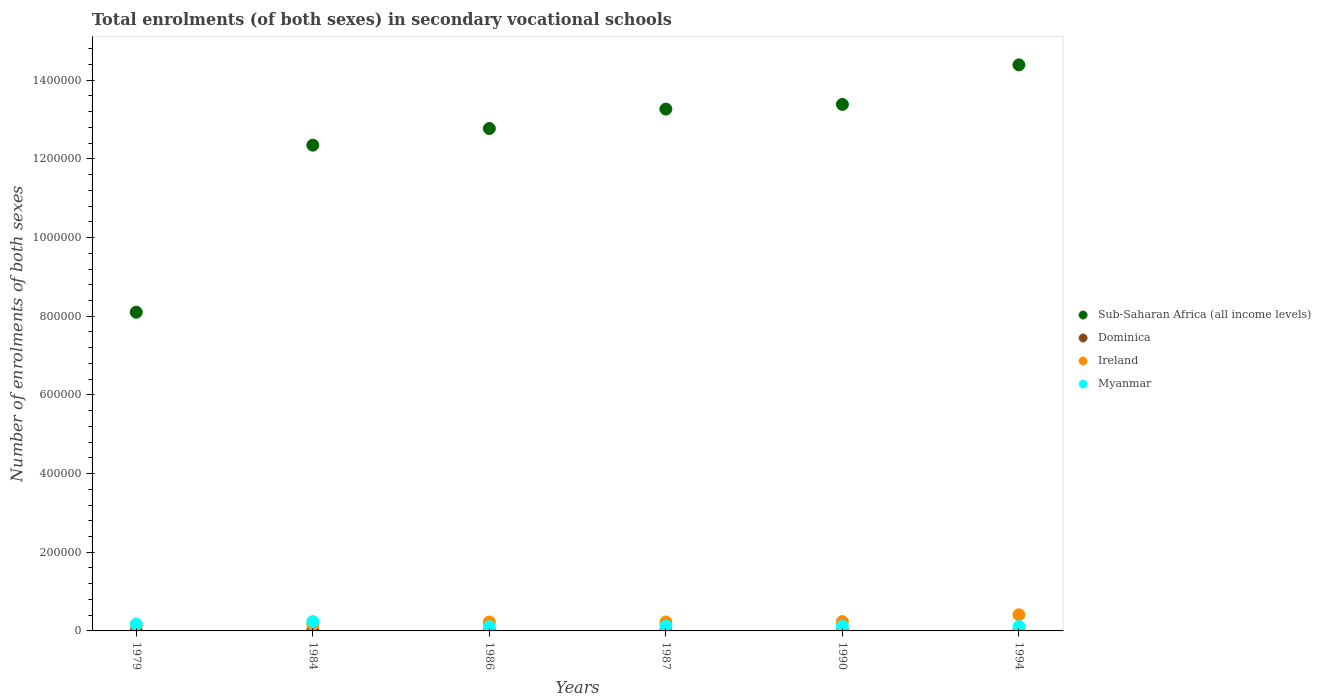Is the number of dotlines equal to the number of legend labels?
Your answer should be very brief. Yes. What is the number of enrolments in secondary schools in Sub-Saharan Africa (all income levels) in 1987?
Provide a succinct answer. 1.33e+06. Across all years, what is the maximum number of enrolments in secondary schools in Ireland?
Make the answer very short. 4.11e+04. Across all years, what is the minimum number of enrolments in secondary schools in Ireland?
Offer a very short reply. 1.47e+04. In which year was the number of enrolments in secondary schools in Dominica maximum?
Your answer should be very brief. 1994. In which year was the number of enrolments in secondary schools in Sub-Saharan Africa (all income levels) minimum?
Your answer should be compact. 1979. What is the total number of enrolments in secondary schools in Sub-Saharan Africa (all income levels) in the graph?
Your response must be concise. 7.43e+06. What is the difference between the number of enrolments in secondary schools in Ireland in 1984 and that in 1987?
Your answer should be compact. -6729. What is the difference between the number of enrolments in secondary schools in Myanmar in 1990 and the number of enrolments in secondary schools in Sub-Saharan Africa (all income levels) in 1987?
Give a very brief answer. -1.32e+06. What is the average number of enrolments in secondary schools in Myanmar per year?
Offer a very short reply. 1.45e+04. In the year 1990, what is the difference between the number of enrolments in secondary schools in Sub-Saharan Africa (all income levels) and number of enrolments in secondary schools in Dominica?
Ensure brevity in your answer.  1.34e+06. What is the ratio of the number of enrolments in secondary schools in Myanmar in 1986 to that in 1987?
Keep it short and to the point. 0.89. What is the difference between the highest and the second highest number of enrolments in secondary schools in Sub-Saharan Africa (all income levels)?
Offer a very short reply. 1.00e+05. What is the difference between the highest and the lowest number of enrolments in secondary schools in Myanmar?
Your response must be concise. 1.28e+04. Is the sum of the number of enrolments in secondary schools in Sub-Saharan Africa (all income levels) in 1984 and 1986 greater than the maximum number of enrolments in secondary schools in Dominica across all years?
Your answer should be very brief. Yes. Are the values on the major ticks of Y-axis written in scientific E-notation?
Provide a succinct answer. No. Does the graph contain any zero values?
Offer a very short reply. No. What is the title of the graph?
Make the answer very short. Total enrolments (of both sexes) in secondary vocational schools. What is the label or title of the X-axis?
Ensure brevity in your answer.  Years. What is the label or title of the Y-axis?
Keep it short and to the point. Number of enrolments of both sexes. What is the Number of enrolments of both sexes of Sub-Saharan Africa (all income levels) in 1979?
Make the answer very short. 8.10e+05. What is the Number of enrolments of both sexes in Dominica in 1979?
Make the answer very short. 436. What is the Number of enrolments of both sexes of Ireland in 1979?
Make the answer very short. 1.47e+04. What is the Number of enrolments of both sexes in Myanmar in 1979?
Make the answer very short. 1.75e+04. What is the Number of enrolments of both sexes of Sub-Saharan Africa (all income levels) in 1984?
Give a very brief answer. 1.23e+06. What is the Number of enrolments of both sexes in Dominica in 1984?
Your response must be concise. 376. What is the Number of enrolments of both sexes of Ireland in 1984?
Give a very brief answer. 1.60e+04. What is the Number of enrolments of both sexes of Myanmar in 1984?
Offer a very short reply. 2.37e+04. What is the Number of enrolments of both sexes of Sub-Saharan Africa (all income levels) in 1986?
Your answer should be compact. 1.28e+06. What is the Number of enrolments of both sexes of Dominica in 1986?
Provide a succinct answer. 259. What is the Number of enrolments of both sexes in Ireland in 1986?
Keep it short and to the point. 2.27e+04. What is the Number of enrolments of both sexes in Myanmar in 1986?
Make the answer very short. 1.09e+04. What is the Number of enrolments of both sexes in Sub-Saharan Africa (all income levels) in 1987?
Give a very brief answer. 1.33e+06. What is the Number of enrolments of both sexes of Ireland in 1987?
Your answer should be compact. 2.27e+04. What is the Number of enrolments of both sexes in Myanmar in 1987?
Give a very brief answer. 1.22e+04. What is the Number of enrolments of both sexes of Sub-Saharan Africa (all income levels) in 1990?
Make the answer very short. 1.34e+06. What is the Number of enrolments of both sexes in Dominica in 1990?
Offer a very short reply. 604. What is the Number of enrolments of both sexes in Ireland in 1990?
Make the answer very short. 2.38e+04. What is the Number of enrolments of both sexes in Myanmar in 1990?
Ensure brevity in your answer.  1.16e+04. What is the Number of enrolments of both sexes of Sub-Saharan Africa (all income levels) in 1994?
Your response must be concise. 1.44e+06. What is the Number of enrolments of both sexes of Dominica in 1994?
Offer a terse response. 800. What is the Number of enrolments of both sexes of Ireland in 1994?
Your answer should be compact. 4.11e+04. What is the Number of enrolments of both sexes of Myanmar in 1994?
Keep it short and to the point. 1.12e+04. Across all years, what is the maximum Number of enrolments of both sexes in Sub-Saharan Africa (all income levels)?
Offer a very short reply. 1.44e+06. Across all years, what is the maximum Number of enrolments of both sexes in Dominica?
Offer a terse response. 800. Across all years, what is the maximum Number of enrolments of both sexes of Ireland?
Ensure brevity in your answer.  4.11e+04. Across all years, what is the maximum Number of enrolments of both sexes in Myanmar?
Keep it short and to the point. 2.37e+04. Across all years, what is the minimum Number of enrolments of both sexes in Sub-Saharan Africa (all income levels)?
Offer a very short reply. 8.10e+05. Across all years, what is the minimum Number of enrolments of both sexes in Dominica?
Your response must be concise. 70. Across all years, what is the minimum Number of enrolments of both sexes of Ireland?
Offer a terse response. 1.47e+04. Across all years, what is the minimum Number of enrolments of both sexes in Myanmar?
Provide a succinct answer. 1.09e+04. What is the total Number of enrolments of both sexes in Sub-Saharan Africa (all income levels) in the graph?
Offer a very short reply. 7.43e+06. What is the total Number of enrolments of both sexes of Dominica in the graph?
Your answer should be compact. 2545. What is the total Number of enrolments of both sexes in Ireland in the graph?
Your response must be concise. 1.41e+05. What is the total Number of enrolments of both sexes in Myanmar in the graph?
Offer a very short reply. 8.70e+04. What is the difference between the Number of enrolments of both sexes of Sub-Saharan Africa (all income levels) in 1979 and that in 1984?
Make the answer very short. -4.25e+05. What is the difference between the Number of enrolments of both sexes in Dominica in 1979 and that in 1984?
Your answer should be very brief. 60. What is the difference between the Number of enrolments of both sexes of Ireland in 1979 and that in 1984?
Ensure brevity in your answer.  -1269. What is the difference between the Number of enrolments of both sexes in Myanmar in 1979 and that in 1984?
Your answer should be compact. -6200. What is the difference between the Number of enrolments of both sexes of Sub-Saharan Africa (all income levels) in 1979 and that in 1986?
Give a very brief answer. -4.67e+05. What is the difference between the Number of enrolments of both sexes of Dominica in 1979 and that in 1986?
Make the answer very short. 177. What is the difference between the Number of enrolments of both sexes in Ireland in 1979 and that in 1986?
Offer a very short reply. -7943. What is the difference between the Number of enrolments of both sexes of Myanmar in 1979 and that in 1986?
Offer a very short reply. 6613. What is the difference between the Number of enrolments of both sexes in Sub-Saharan Africa (all income levels) in 1979 and that in 1987?
Your answer should be compact. -5.16e+05. What is the difference between the Number of enrolments of both sexes of Dominica in 1979 and that in 1987?
Keep it short and to the point. 366. What is the difference between the Number of enrolments of both sexes in Ireland in 1979 and that in 1987?
Ensure brevity in your answer.  -7998. What is the difference between the Number of enrolments of both sexes in Myanmar in 1979 and that in 1987?
Ensure brevity in your answer.  5295. What is the difference between the Number of enrolments of both sexes in Sub-Saharan Africa (all income levels) in 1979 and that in 1990?
Give a very brief answer. -5.28e+05. What is the difference between the Number of enrolments of both sexes in Dominica in 1979 and that in 1990?
Your answer should be compact. -168. What is the difference between the Number of enrolments of both sexes of Ireland in 1979 and that in 1990?
Offer a terse response. -9034. What is the difference between the Number of enrolments of both sexes in Myanmar in 1979 and that in 1990?
Provide a short and direct response. 5939. What is the difference between the Number of enrolments of both sexes in Sub-Saharan Africa (all income levels) in 1979 and that in 1994?
Ensure brevity in your answer.  -6.29e+05. What is the difference between the Number of enrolments of both sexes of Dominica in 1979 and that in 1994?
Your response must be concise. -364. What is the difference between the Number of enrolments of both sexes in Ireland in 1979 and that in 1994?
Offer a very short reply. -2.63e+04. What is the difference between the Number of enrolments of both sexes of Myanmar in 1979 and that in 1994?
Provide a short and direct response. 6337. What is the difference between the Number of enrolments of both sexes in Sub-Saharan Africa (all income levels) in 1984 and that in 1986?
Offer a very short reply. -4.24e+04. What is the difference between the Number of enrolments of both sexes of Dominica in 1984 and that in 1986?
Your answer should be compact. 117. What is the difference between the Number of enrolments of both sexes of Ireland in 1984 and that in 1986?
Give a very brief answer. -6674. What is the difference between the Number of enrolments of both sexes of Myanmar in 1984 and that in 1986?
Provide a succinct answer. 1.28e+04. What is the difference between the Number of enrolments of both sexes of Sub-Saharan Africa (all income levels) in 1984 and that in 1987?
Offer a terse response. -9.17e+04. What is the difference between the Number of enrolments of both sexes in Dominica in 1984 and that in 1987?
Ensure brevity in your answer.  306. What is the difference between the Number of enrolments of both sexes of Ireland in 1984 and that in 1987?
Give a very brief answer. -6729. What is the difference between the Number of enrolments of both sexes in Myanmar in 1984 and that in 1987?
Give a very brief answer. 1.15e+04. What is the difference between the Number of enrolments of both sexes of Sub-Saharan Africa (all income levels) in 1984 and that in 1990?
Offer a terse response. -1.04e+05. What is the difference between the Number of enrolments of both sexes in Dominica in 1984 and that in 1990?
Your answer should be compact. -228. What is the difference between the Number of enrolments of both sexes of Ireland in 1984 and that in 1990?
Your response must be concise. -7765. What is the difference between the Number of enrolments of both sexes of Myanmar in 1984 and that in 1990?
Offer a terse response. 1.21e+04. What is the difference between the Number of enrolments of both sexes in Sub-Saharan Africa (all income levels) in 1984 and that in 1994?
Keep it short and to the point. -2.04e+05. What is the difference between the Number of enrolments of both sexes in Dominica in 1984 and that in 1994?
Provide a short and direct response. -424. What is the difference between the Number of enrolments of both sexes of Ireland in 1984 and that in 1994?
Make the answer very short. -2.51e+04. What is the difference between the Number of enrolments of both sexes in Myanmar in 1984 and that in 1994?
Give a very brief answer. 1.25e+04. What is the difference between the Number of enrolments of both sexes of Sub-Saharan Africa (all income levels) in 1986 and that in 1987?
Offer a terse response. -4.94e+04. What is the difference between the Number of enrolments of both sexes in Dominica in 1986 and that in 1987?
Your answer should be very brief. 189. What is the difference between the Number of enrolments of both sexes in Ireland in 1986 and that in 1987?
Make the answer very short. -55. What is the difference between the Number of enrolments of both sexes in Myanmar in 1986 and that in 1987?
Provide a succinct answer. -1318. What is the difference between the Number of enrolments of both sexes in Sub-Saharan Africa (all income levels) in 1986 and that in 1990?
Offer a very short reply. -6.13e+04. What is the difference between the Number of enrolments of both sexes in Dominica in 1986 and that in 1990?
Provide a succinct answer. -345. What is the difference between the Number of enrolments of both sexes of Ireland in 1986 and that in 1990?
Provide a short and direct response. -1091. What is the difference between the Number of enrolments of both sexes in Myanmar in 1986 and that in 1990?
Make the answer very short. -674. What is the difference between the Number of enrolments of both sexes in Sub-Saharan Africa (all income levels) in 1986 and that in 1994?
Your answer should be very brief. -1.62e+05. What is the difference between the Number of enrolments of both sexes in Dominica in 1986 and that in 1994?
Offer a terse response. -541. What is the difference between the Number of enrolments of both sexes in Ireland in 1986 and that in 1994?
Your answer should be compact. -1.84e+04. What is the difference between the Number of enrolments of both sexes of Myanmar in 1986 and that in 1994?
Offer a terse response. -276. What is the difference between the Number of enrolments of both sexes in Sub-Saharan Africa (all income levels) in 1987 and that in 1990?
Ensure brevity in your answer.  -1.19e+04. What is the difference between the Number of enrolments of both sexes in Dominica in 1987 and that in 1990?
Your answer should be compact. -534. What is the difference between the Number of enrolments of both sexes of Ireland in 1987 and that in 1990?
Ensure brevity in your answer.  -1036. What is the difference between the Number of enrolments of both sexes of Myanmar in 1987 and that in 1990?
Your response must be concise. 644. What is the difference between the Number of enrolments of both sexes in Sub-Saharan Africa (all income levels) in 1987 and that in 1994?
Your answer should be compact. -1.12e+05. What is the difference between the Number of enrolments of both sexes of Dominica in 1987 and that in 1994?
Give a very brief answer. -730. What is the difference between the Number of enrolments of both sexes in Ireland in 1987 and that in 1994?
Give a very brief answer. -1.83e+04. What is the difference between the Number of enrolments of both sexes in Myanmar in 1987 and that in 1994?
Keep it short and to the point. 1042. What is the difference between the Number of enrolments of both sexes of Sub-Saharan Africa (all income levels) in 1990 and that in 1994?
Keep it short and to the point. -1.00e+05. What is the difference between the Number of enrolments of both sexes of Dominica in 1990 and that in 1994?
Your answer should be compact. -196. What is the difference between the Number of enrolments of both sexes of Ireland in 1990 and that in 1994?
Your answer should be very brief. -1.73e+04. What is the difference between the Number of enrolments of both sexes of Myanmar in 1990 and that in 1994?
Provide a short and direct response. 398. What is the difference between the Number of enrolments of both sexes of Sub-Saharan Africa (all income levels) in 1979 and the Number of enrolments of both sexes of Dominica in 1984?
Your response must be concise. 8.10e+05. What is the difference between the Number of enrolments of both sexes in Sub-Saharan Africa (all income levels) in 1979 and the Number of enrolments of both sexes in Ireland in 1984?
Offer a terse response. 7.94e+05. What is the difference between the Number of enrolments of both sexes of Sub-Saharan Africa (all income levels) in 1979 and the Number of enrolments of both sexes of Myanmar in 1984?
Provide a succinct answer. 7.87e+05. What is the difference between the Number of enrolments of both sexes in Dominica in 1979 and the Number of enrolments of both sexes in Ireland in 1984?
Your answer should be very brief. -1.56e+04. What is the difference between the Number of enrolments of both sexes of Dominica in 1979 and the Number of enrolments of both sexes of Myanmar in 1984?
Provide a succinct answer. -2.33e+04. What is the difference between the Number of enrolments of both sexes in Ireland in 1979 and the Number of enrolments of both sexes in Myanmar in 1984?
Offer a very short reply. -8971. What is the difference between the Number of enrolments of both sexes in Sub-Saharan Africa (all income levels) in 1979 and the Number of enrolments of both sexes in Dominica in 1986?
Your answer should be compact. 8.10e+05. What is the difference between the Number of enrolments of both sexes in Sub-Saharan Africa (all income levels) in 1979 and the Number of enrolments of both sexes in Ireland in 1986?
Your response must be concise. 7.88e+05. What is the difference between the Number of enrolments of both sexes of Sub-Saharan Africa (all income levels) in 1979 and the Number of enrolments of both sexes of Myanmar in 1986?
Your answer should be very brief. 7.99e+05. What is the difference between the Number of enrolments of both sexes of Dominica in 1979 and the Number of enrolments of both sexes of Ireland in 1986?
Your response must be concise. -2.22e+04. What is the difference between the Number of enrolments of both sexes in Dominica in 1979 and the Number of enrolments of both sexes in Myanmar in 1986?
Provide a succinct answer. -1.05e+04. What is the difference between the Number of enrolments of both sexes in Ireland in 1979 and the Number of enrolments of both sexes in Myanmar in 1986?
Your answer should be very brief. 3842. What is the difference between the Number of enrolments of both sexes of Sub-Saharan Africa (all income levels) in 1979 and the Number of enrolments of both sexes of Dominica in 1987?
Provide a succinct answer. 8.10e+05. What is the difference between the Number of enrolments of both sexes in Sub-Saharan Africa (all income levels) in 1979 and the Number of enrolments of both sexes in Ireland in 1987?
Your answer should be compact. 7.87e+05. What is the difference between the Number of enrolments of both sexes in Sub-Saharan Africa (all income levels) in 1979 and the Number of enrolments of both sexes in Myanmar in 1987?
Your response must be concise. 7.98e+05. What is the difference between the Number of enrolments of both sexes of Dominica in 1979 and the Number of enrolments of both sexes of Ireland in 1987?
Your answer should be compact. -2.23e+04. What is the difference between the Number of enrolments of both sexes in Dominica in 1979 and the Number of enrolments of both sexes in Myanmar in 1987?
Provide a short and direct response. -1.18e+04. What is the difference between the Number of enrolments of both sexes in Ireland in 1979 and the Number of enrolments of both sexes in Myanmar in 1987?
Your response must be concise. 2524. What is the difference between the Number of enrolments of both sexes of Sub-Saharan Africa (all income levels) in 1979 and the Number of enrolments of both sexes of Dominica in 1990?
Offer a terse response. 8.10e+05. What is the difference between the Number of enrolments of both sexes in Sub-Saharan Africa (all income levels) in 1979 and the Number of enrolments of both sexes in Ireland in 1990?
Offer a terse response. 7.86e+05. What is the difference between the Number of enrolments of both sexes of Sub-Saharan Africa (all income levels) in 1979 and the Number of enrolments of both sexes of Myanmar in 1990?
Your response must be concise. 7.99e+05. What is the difference between the Number of enrolments of both sexes of Dominica in 1979 and the Number of enrolments of both sexes of Ireland in 1990?
Your answer should be very brief. -2.33e+04. What is the difference between the Number of enrolments of both sexes of Dominica in 1979 and the Number of enrolments of both sexes of Myanmar in 1990?
Give a very brief answer. -1.11e+04. What is the difference between the Number of enrolments of both sexes in Ireland in 1979 and the Number of enrolments of both sexes in Myanmar in 1990?
Keep it short and to the point. 3168. What is the difference between the Number of enrolments of both sexes of Sub-Saharan Africa (all income levels) in 1979 and the Number of enrolments of both sexes of Dominica in 1994?
Your answer should be compact. 8.09e+05. What is the difference between the Number of enrolments of both sexes in Sub-Saharan Africa (all income levels) in 1979 and the Number of enrolments of both sexes in Ireland in 1994?
Your answer should be compact. 7.69e+05. What is the difference between the Number of enrolments of both sexes in Sub-Saharan Africa (all income levels) in 1979 and the Number of enrolments of both sexes in Myanmar in 1994?
Give a very brief answer. 7.99e+05. What is the difference between the Number of enrolments of both sexes of Dominica in 1979 and the Number of enrolments of both sexes of Ireland in 1994?
Your answer should be very brief. -4.06e+04. What is the difference between the Number of enrolments of both sexes in Dominica in 1979 and the Number of enrolments of both sexes in Myanmar in 1994?
Keep it short and to the point. -1.07e+04. What is the difference between the Number of enrolments of both sexes of Ireland in 1979 and the Number of enrolments of both sexes of Myanmar in 1994?
Your answer should be very brief. 3566. What is the difference between the Number of enrolments of both sexes in Sub-Saharan Africa (all income levels) in 1984 and the Number of enrolments of both sexes in Dominica in 1986?
Provide a succinct answer. 1.23e+06. What is the difference between the Number of enrolments of both sexes in Sub-Saharan Africa (all income levels) in 1984 and the Number of enrolments of both sexes in Ireland in 1986?
Your response must be concise. 1.21e+06. What is the difference between the Number of enrolments of both sexes in Sub-Saharan Africa (all income levels) in 1984 and the Number of enrolments of both sexes in Myanmar in 1986?
Your answer should be very brief. 1.22e+06. What is the difference between the Number of enrolments of both sexes in Dominica in 1984 and the Number of enrolments of both sexes in Ireland in 1986?
Make the answer very short. -2.23e+04. What is the difference between the Number of enrolments of both sexes in Dominica in 1984 and the Number of enrolments of both sexes in Myanmar in 1986?
Provide a succinct answer. -1.05e+04. What is the difference between the Number of enrolments of both sexes of Ireland in 1984 and the Number of enrolments of both sexes of Myanmar in 1986?
Offer a very short reply. 5111. What is the difference between the Number of enrolments of both sexes in Sub-Saharan Africa (all income levels) in 1984 and the Number of enrolments of both sexes in Dominica in 1987?
Your answer should be compact. 1.23e+06. What is the difference between the Number of enrolments of both sexes in Sub-Saharan Africa (all income levels) in 1984 and the Number of enrolments of both sexes in Ireland in 1987?
Ensure brevity in your answer.  1.21e+06. What is the difference between the Number of enrolments of both sexes in Sub-Saharan Africa (all income levels) in 1984 and the Number of enrolments of both sexes in Myanmar in 1987?
Provide a succinct answer. 1.22e+06. What is the difference between the Number of enrolments of both sexes of Dominica in 1984 and the Number of enrolments of both sexes of Ireland in 1987?
Your answer should be very brief. -2.24e+04. What is the difference between the Number of enrolments of both sexes in Dominica in 1984 and the Number of enrolments of both sexes in Myanmar in 1987?
Your answer should be very brief. -1.18e+04. What is the difference between the Number of enrolments of both sexes of Ireland in 1984 and the Number of enrolments of both sexes of Myanmar in 1987?
Offer a terse response. 3793. What is the difference between the Number of enrolments of both sexes of Sub-Saharan Africa (all income levels) in 1984 and the Number of enrolments of both sexes of Dominica in 1990?
Your response must be concise. 1.23e+06. What is the difference between the Number of enrolments of both sexes in Sub-Saharan Africa (all income levels) in 1984 and the Number of enrolments of both sexes in Ireland in 1990?
Your answer should be compact. 1.21e+06. What is the difference between the Number of enrolments of both sexes in Sub-Saharan Africa (all income levels) in 1984 and the Number of enrolments of both sexes in Myanmar in 1990?
Keep it short and to the point. 1.22e+06. What is the difference between the Number of enrolments of both sexes of Dominica in 1984 and the Number of enrolments of both sexes of Ireland in 1990?
Ensure brevity in your answer.  -2.34e+04. What is the difference between the Number of enrolments of both sexes of Dominica in 1984 and the Number of enrolments of both sexes of Myanmar in 1990?
Offer a very short reply. -1.12e+04. What is the difference between the Number of enrolments of both sexes in Ireland in 1984 and the Number of enrolments of both sexes in Myanmar in 1990?
Ensure brevity in your answer.  4437. What is the difference between the Number of enrolments of both sexes in Sub-Saharan Africa (all income levels) in 1984 and the Number of enrolments of both sexes in Dominica in 1994?
Your response must be concise. 1.23e+06. What is the difference between the Number of enrolments of both sexes in Sub-Saharan Africa (all income levels) in 1984 and the Number of enrolments of both sexes in Ireland in 1994?
Give a very brief answer. 1.19e+06. What is the difference between the Number of enrolments of both sexes in Sub-Saharan Africa (all income levels) in 1984 and the Number of enrolments of both sexes in Myanmar in 1994?
Give a very brief answer. 1.22e+06. What is the difference between the Number of enrolments of both sexes of Dominica in 1984 and the Number of enrolments of both sexes of Ireland in 1994?
Your response must be concise. -4.07e+04. What is the difference between the Number of enrolments of both sexes of Dominica in 1984 and the Number of enrolments of both sexes of Myanmar in 1994?
Your response must be concise. -1.08e+04. What is the difference between the Number of enrolments of both sexes of Ireland in 1984 and the Number of enrolments of both sexes of Myanmar in 1994?
Your response must be concise. 4835. What is the difference between the Number of enrolments of both sexes in Sub-Saharan Africa (all income levels) in 1986 and the Number of enrolments of both sexes in Dominica in 1987?
Make the answer very short. 1.28e+06. What is the difference between the Number of enrolments of both sexes of Sub-Saharan Africa (all income levels) in 1986 and the Number of enrolments of both sexes of Ireland in 1987?
Make the answer very short. 1.25e+06. What is the difference between the Number of enrolments of both sexes of Sub-Saharan Africa (all income levels) in 1986 and the Number of enrolments of both sexes of Myanmar in 1987?
Provide a succinct answer. 1.27e+06. What is the difference between the Number of enrolments of both sexes of Dominica in 1986 and the Number of enrolments of both sexes of Ireland in 1987?
Your response must be concise. -2.25e+04. What is the difference between the Number of enrolments of both sexes in Dominica in 1986 and the Number of enrolments of both sexes in Myanmar in 1987?
Your response must be concise. -1.19e+04. What is the difference between the Number of enrolments of both sexes of Ireland in 1986 and the Number of enrolments of both sexes of Myanmar in 1987?
Your answer should be very brief. 1.05e+04. What is the difference between the Number of enrolments of both sexes in Sub-Saharan Africa (all income levels) in 1986 and the Number of enrolments of both sexes in Dominica in 1990?
Give a very brief answer. 1.28e+06. What is the difference between the Number of enrolments of both sexes in Sub-Saharan Africa (all income levels) in 1986 and the Number of enrolments of both sexes in Ireland in 1990?
Make the answer very short. 1.25e+06. What is the difference between the Number of enrolments of both sexes of Sub-Saharan Africa (all income levels) in 1986 and the Number of enrolments of both sexes of Myanmar in 1990?
Give a very brief answer. 1.27e+06. What is the difference between the Number of enrolments of both sexes of Dominica in 1986 and the Number of enrolments of both sexes of Ireland in 1990?
Provide a short and direct response. -2.35e+04. What is the difference between the Number of enrolments of both sexes of Dominica in 1986 and the Number of enrolments of both sexes of Myanmar in 1990?
Make the answer very short. -1.13e+04. What is the difference between the Number of enrolments of both sexes of Ireland in 1986 and the Number of enrolments of both sexes of Myanmar in 1990?
Provide a succinct answer. 1.11e+04. What is the difference between the Number of enrolments of both sexes of Sub-Saharan Africa (all income levels) in 1986 and the Number of enrolments of both sexes of Dominica in 1994?
Make the answer very short. 1.28e+06. What is the difference between the Number of enrolments of both sexes in Sub-Saharan Africa (all income levels) in 1986 and the Number of enrolments of both sexes in Ireland in 1994?
Provide a short and direct response. 1.24e+06. What is the difference between the Number of enrolments of both sexes of Sub-Saharan Africa (all income levels) in 1986 and the Number of enrolments of both sexes of Myanmar in 1994?
Your answer should be compact. 1.27e+06. What is the difference between the Number of enrolments of both sexes of Dominica in 1986 and the Number of enrolments of both sexes of Ireland in 1994?
Offer a terse response. -4.08e+04. What is the difference between the Number of enrolments of both sexes of Dominica in 1986 and the Number of enrolments of both sexes of Myanmar in 1994?
Your answer should be compact. -1.09e+04. What is the difference between the Number of enrolments of both sexes of Ireland in 1986 and the Number of enrolments of both sexes of Myanmar in 1994?
Your answer should be very brief. 1.15e+04. What is the difference between the Number of enrolments of both sexes of Sub-Saharan Africa (all income levels) in 1987 and the Number of enrolments of both sexes of Dominica in 1990?
Offer a terse response. 1.33e+06. What is the difference between the Number of enrolments of both sexes in Sub-Saharan Africa (all income levels) in 1987 and the Number of enrolments of both sexes in Ireland in 1990?
Your response must be concise. 1.30e+06. What is the difference between the Number of enrolments of both sexes in Sub-Saharan Africa (all income levels) in 1987 and the Number of enrolments of both sexes in Myanmar in 1990?
Provide a short and direct response. 1.32e+06. What is the difference between the Number of enrolments of both sexes of Dominica in 1987 and the Number of enrolments of both sexes of Ireland in 1990?
Your response must be concise. -2.37e+04. What is the difference between the Number of enrolments of both sexes of Dominica in 1987 and the Number of enrolments of both sexes of Myanmar in 1990?
Give a very brief answer. -1.15e+04. What is the difference between the Number of enrolments of both sexes of Ireland in 1987 and the Number of enrolments of both sexes of Myanmar in 1990?
Provide a succinct answer. 1.12e+04. What is the difference between the Number of enrolments of both sexes of Sub-Saharan Africa (all income levels) in 1987 and the Number of enrolments of both sexes of Dominica in 1994?
Make the answer very short. 1.33e+06. What is the difference between the Number of enrolments of both sexes of Sub-Saharan Africa (all income levels) in 1987 and the Number of enrolments of both sexes of Ireland in 1994?
Your answer should be compact. 1.29e+06. What is the difference between the Number of enrolments of both sexes in Sub-Saharan Africa (all income levels) in 1987 and the Number of enrolments of both sexes in Myanmar in 1994?
Offer a very short reply. 1.32e+06. What is the difference between the Number of enrolments of both sexes in Dominica in 1987 and the Number of enrolments of both sexes in Ireland in 1994?
Your answer should be compact. -4.10e+04. What is the difference between the Number of enrolments of both sexes in Dominica in 1987 and the Number of enrolments of both sexes in Myanmar in 1994?
Ensure brevity in your answer.  -1.11e+04. What is the difference between the Number of enrolments of both sexes of Ireland in 1987 and the Number of enrolments of both sexes of Myanmar in 1994?
Keep it short and to the point. 1.16e+04. What is the difference between the Number of enrolments of both sexes of Sub-Saharan Africa (all income levels) in 1990 and the Number of enrolments of both sexes of Dominica in 1994?
Give a very brief answer. 1.34e+06. What is the difference between the Number of enrolments of both sexes of Sub-Saharan Africa (all income levels) in 1990 and the Number of enrolments of both sexes of Ireland in 1994?
Your response must be concise. 1.30e+06. What is the difference between the Number of enrolments of both sexes of Sub-Saharan Africa (all income levels) in 1990 and the Number of enrolments of both sexes of Myanmar in 1994?
Provide a succinct answer. 1.33e+06. What is the difference between the Number of enrolments of both sexes in Dominica in 1990 and the Number of enrolments of both sexes in Ireland in 1994?
Your answer should be very brief. -4.05e+04. What is the difference between the Number of enrolments of both sexes in Dominica in 1990 and the Number of enrolments of both sexes in Myanmar in 1994?
Your answer should be compact. -1.06e+04. What is the difference between the Number of enrolments of both sexes in Ireland in 1990 and the Number of enrolments of both sexes in Myanmar in 1994?
Give a very brief answer. 1.26e+04. What is the average Number of enrolments of both sexes of Sub-Saharan Africa (all income levels) per year?
Keep it short and to the point. 1.24e+06. What is the average Number of enrolments of both sexes of Dominica per year?
Your answer should be very brief. 424.17. What is the average Number of enrolments of both sexes in Ireland per year?
Offer a terse response. 2.35e+04. What is the average Number of enrolments of both sexes of Myanmar per year?
Offer a terse response. 1.45e+04. In the year 1979, what is the difference between the Number of enrolments of both sexes of Sub-Saharan Africa (all income levels) and Number of enrolments of both sexes of Dominica?
Offer a very short reply. 8.10e+05. In the year 1979, what is the difference between the Number of enrolments of both sexes of Sub-Saharan Africa (all income levels) and Number of enrolments of both sexes of Ireland?
Give a very brief answer. 7.95e+05. In the year 1979, what is the difference between the Number of enrolments of both sexes of Sub-Saharan Africa (all income levels) and Number of enrolments of both sexes of Myanmar?
Offer a very short reply. 7.93e+05. In the year 1979, what is the difference between the Number of enrolments of both sexes in Dominica and Number of enrolments of both sexes in Ireland?
Provide a succinct answer. -1.43e+04. In the year 1979, what is the difference between the Number of enrolments of both sexes of Dominica and Number of enrolments of both sexes of Myanmar?
Provide a short and direct response. -1.71e+04. In the year 1979, what is the difference between the Number of enrolments of both sexes of Ireland and Number of enrolments of both sexes of Myanmar?
Your answer should be very brief. -2771. In the year 1984, what is the difference between the Number of enrolments of both sexes of Sub-Saharan Africa (all income levels) and Number of enrolments of both sexes of Dominica?
Keep it short and to the point. 1.23e+06. In the year 1984, what is the difference between the Number of enrolments of both sexes in Sub-Saharan Africa (all income levels) and Number of enrolments of both sexes in Ireland?
Ensure brevity in your answer.  1.22e+06. In the year 1984, what is the difference between the Number of enrolments of both sexes of Sub-Saharan Africa (all income levels) and Number of enrolments of both sexes of Myanmar?
Provide a short and direct response. 1.21e+06. In the year 1984, what is the difference between the Number of enrolments of both sexes in Dominica and Number of enrolments of both sexes in Ireland?
Keep it short and to the point. -1.56e+04. In the year 1984, what is the difference between the Number of enrolments of both sexes in Dominica and Number of enrolments of both sexes in Myanmar?
Your response must be concise. -2.33e+04. In the year 1984, what is the difference between the Number of enrolments of both sexes in Ireland and Number of enrolments of both sexes in Myanmar?
Ensure brevity in your answer.  -7702. In the year 1986, what is the difference between the Number of enrolments of both sexes of Sub-Saharan Africa (all income levels) and Number of enrolments of both sexes of Dominica?
Give a very brief answer. 1.28e+06. In the year 1986, what is the difference between the Number of enrolments of both sexes of Sub-Saharan Africa (all income levels) and Number of enrolments of both sexes of Ireland?
Provide a succinct answer. 1.25e+06. In the year 1986, what is the difference between the Number of enrolments of both sexes in Sub-Saharan Africa (all income levels) and Number of enrolments of both sexes in Myanmar?
Provide a short and direct response. 1.27e+06. In the year 1986, what is the difference between the Number of enrolments of both sexes of Dominica and Number of enrolments of both sexes of Ireland?
Provide a short and direct response. -2.24e+04. In the year 1986, what is the difference between the Number of enrolments of both sexes of Dominica and Number of enrolments of both sexes of Myanmar?
Provide a short and direct response. -1.06e+04. In the year 1986, what is the difference between the Number of enrolments of both sexes in Ireland and Number of enrolments of both sexes in Myanmar?
Offer a very short reply. 1.18e+04. In the year 1987, what is the difference between the Number of enrolments of both sexes in Sub-Saharan Africa (all income levels) and Number of enrolments of both sexes in Dominica?
Offer a terse response. 1.33e+06. In the year 1987, what is the difference between the Number of enrolments of both sexes in Sub-Saharan Africa (all income levels) and Number of enrolments of both sexes in Ireland?
Your answer should be compact. 1.30e+06. In the year 1987, what is the difference between the Number of enrolments of both sexes in Sub-Saharan Africa (all income levels) and Number of enrolments of both sexes in Myanmar?
Make the answer very short. 1.31e+06. In the year 1987, what is the difference between the Number of enrolments of both sexes of Dominica and Number of enrolments of both sexes of Ireland?
Make the answer very short. -2.27e+04. In the year 1987, what is the difference between the Number of enrolments of both sexes in Dominica and Number of enrolments of both sexes in Myanmar?
Provide a short and direct response. -1.21e+04. In the year 1987, what is the difference between the Number of enrolments of both sexes of Ireland and Number of enrolments of both sexes of Myanmar?
Make the answer very short. 1.05e+04. In the year 1990, what is the difference between the Number of enrolments of both sexes in Sub-Saharan Africa (all income levels) and Number of enrolments of both sexes in Dominica?
Your answer should be very brief. 1.34e+06. In the year 1990, what is the difference between the Number of enrolments of both sexes of Sub-Saharan Africa (all income levels) and Number of enrolments of both sexes of Ireland?
Provide a succinct answer. 1.31e+06. In the year 1990, what is the difference between the Number of enrolments of both sexes in Sub-Saharan Africa (all income levels) and Number of enrolments of both sexes in Myanmar?
Give a very brief answer. 1.33e+06. In the year 1990, what is the difference between the Number of enrolments of both sexes in Dominica and Number of enrolments of both sexes in Ireland?
Give a very brief answer. -2.32e+04. In the year 1990, what is the difference between the Number of enrolments of both sexes in Dominica and Number of enrolments of both sexes in Myanmar?
Keep it short and to the point. -1.10e+04. In the year 1990, what is the difference between the Number of enrolments of both sexes in Ireland and Number of enrolments of both sexes in Myanmar?
Your answer should be very brief. 1.22e+04. In the year 1994, what is the difference between the Number of enrolments of both sexes of Sub-Saharan Africa (all income levels) and Number of enrolments of both sexes of Dominica?
Provide a short and direct response. 1.44e+06. In the year 1994, what is the difference between the Number of enrolments of both sexes in Sub-Saharan Africa (all income levels) and Number of enrolments of both sexes in Ireland?
Your response must be concise. 1.40e+06. In the year 1994, what is the difference between the Number of enrolments of both sexes of Sub-Saharan Africa (all income levels) and Number of enrolments of both sexes of Myanmar?
Ensure brevity in your answer.  1.43e+06. In the year 1994, what is the difference between the Number of enrolments of both sexes in Dominica and Number of enrolments of both sexes in Ireland?
Provide a short and direct response. -4.03e+04. In the year 1994, what is the difference between the Number of enrolments of both sexes of Dominica and Number of enrolments of both sexes of Myanmar?
Provide a short and direct response. -1.04e+04. In the year 1994, what is the difference between the Number of enrolments of both sexes in Ireland and Number of enrolments of both sexes in Myanmar?
Offer a terse response. 2.99e+04. What is the ratio of the Number of enrolments of both sexes of Sub-Saharan Africa (all income levels) in 1979 to that in 1984?
Offer a very short reply. 0.66. What is the ratio of the Number of enrolments of both sexes of Dominica in 1979 to that in 1984?
Give a very brief answer. 1.16. What is the ratio of the Number of enrolments of both sexes in Ireland in 1979 to that in 1984?
Provide a succinct answer. 0.92. What is the ratio of the Number of enrolments of both sexes of Myanmar in 1979 to that in 1984?
Keep it short and to the point. 0.74. What is the ratio of the Number of enrolments of both sexes in Sub-Saharan Africa (all income levels) in 1979 to that in 1986?
Provide a short and direct response. 0.63. What is the ratio of the Number of enrolments of both sexes of Dominica in 1979 to that in 1986?
Ensure brevity in your answer.  1.68. What is the ratio of the Number of enrolments of both sexes in Ireland in 1979 to that in 1986?
Your answer should be very brief. 0.65. What is the ratio of the Number of enrolments of both sexes of Myanmar in 1979 to that in 1986?
Your answer should be very brief. 1.61. What is the ratio of the Number of enrolments of both sexes of Sub-Saharan Africa (all income levels) in 1979 to that in 1987?
Your answer should be very brief. 0.61. What is the ratio of the Number of enrolments of both sexes in Dominica in 1979 to that in 1987?
Your answer should be very brief. 6.23. What is the ratio of the Number of enrolments of both sexes in Ireland in 1979 to that in 1987?
Your answer should be very brief. 0.65. What is the ratio of the Number of enrolments of both sexes of Myanmar in 1979 to that in 1987?
Give a very brief answer. 1.43. What is the ratio of the Number of enrolments of both sexes in Sub-Saharan Africa (all income levels) in 1979 to that in 1990?
Give a very brief answer. 0.61. What is the ratio of the Number of enrolments of both sexes in Dominica in 1979 to that in 1990?
Offer a terse response. 0.72. What is the ratio of the Number of enrolments of both sexes in Ireland in 1979 to that in 1990?
Provide a short and direct response. 0.62. What is the ratio of the Number of enrolments of both sexes of Myanmar in 1979 to that in 1990?
Keep it short and to the point. 1.51. What is the ratio of the Number of enrolments of both sexes in Sub-Saharan Africa (all income levels) in 1979 to that in 1994?
Give a very brief answer. 0.56. What is the ratio of the Number of enrolments of both sexes of Dominica in 1979 to that in 1994?
Your answer should be compact. 0.55. What is the ratio of the Number of enrolments of both sexes of Ireland in 1979 to that in 1994?
Provide a short and direct response. 0.36. What is the ratio of the Number of enrolments of both sexes of Myanmar in 1979 to that in 1994?
Give a very brief answer. 1.57. What is the ratio of the Number of enrolments of both sexes in Sub-Saharan Africa (all income levels) in 1984 to that in 1986?
Keep it short and to the point. 0.97. What is the ratio of the Number of enrolments of both sexes of Dominica in 1984 to that in 1986?
Provide a short and direct response. 1.45. What is the ratio of the Number of enrolments of both sexes of Ireland in 1984 to that in 1986?
Offer a very short reply. 0.71. What is the ratio of the Number of enrolments of both sexes in Myanmar in 1984 to that in 1986?
Offer a terse response. 2.18. What is the ratio of the Number of enrolments of both sexes in Sub-Saharan Africa (all income levels) in 1984 to that in 1987?
Offer a very short reply. 0.93. What is the ratio of the Number of enrolments of both sexes of Dominica in 1984 to that in 1987?
Ensure brevity in your answer.  5.37. What is the ratio of the Number of enrolments of both sexes of Ireland in 1984 to that in 1987?
Offer a very short reply. 0.7. What is the ratio of the Number of enrolments of both sexes of Myanmar in 1984 to that in 1987?
Keep it short and to the point. 1.94. What is the ratio of the Number of enrolments of both sexes of Sub-Saharan Africa (all income levels) in 1984 to that in 1990?
Ensure brevity in your answer.  0.92. What is the ratio of the Number of enrolments of both sexes of Dominica in 1984 to that in 1990?
Provide a short and direct response. 0.62. What is the ratio of the Number of enrolments of both sexes of Ireland in 1984 to that in 1990?
Give a very brief answer. 0.67. What is the ratio of the Number of enrolments of both sexes of Myanmar in 1984 to that in 1990?
Offer a terse response. 2.05. What is the ratio of the Number of enrolments of both sexes in Sub-Saharan Africa (all income levels) in 1984 to that in 1994?
Provide a short and direct response. 0.86. What is the ratio of the Number of enrolments of both sexes of Dominica in 1984 to that in 1994?
Make the answer very short. 0.47. What is the ratio of the Number of enrolments of both sexes of Ireland in 1984 to that in 1994?
Give a very brief answer. 0.39. What is the ratio of the Number of enrolments of both sexes of Myanmar in 1984 to that in 1994?
Ensure brevity in your answer.  2.12. What is the ratio of the Number of enrolments of both sexes in Sub-Saharan Africa (all income levels) in 1986 to that in 1987?
Keep it short and to the point. 0.96. What is the ratio of the Number of enrolments of both sexes in Ireland in 1986 to that in 1987?
Provide a succinct answer. 1. What is the ratio of the Number of enrolments of both sexes in Myanmar in 1986 to that in 1987?
Provide a short and direct response. 0.89. What is the ratio of the Number of enrolments of both sexes of Sub-Saharan Africa (all income levels) in 1986 to that in 1990?
Your answer should be compact. 0.95. What is the ratio of the Number of enrolments of both sexes of Dominica in 1986 to that in 1990?
Offer a very short reply. 0.43. What is the ratio of the Number of enrolments of both sexes in Ireland in 1986 to that in 1990?
Offer a terse response. 0.95. What is the ratio of the Number of enrolments of both sexes of Myanmar in 1986 to that in 1990?
Your response must be concise. 0.94. What is the ratio of the Number of enrolments of both sexes in Sub-Saharan Africa (all income levels) in 1986 to that in 1994?
Give a very brief answer. 0.89. What is the ratio of the Number of enrolments of both sexes in Dominica in 1986 to that in 1994?
Offer a terse response. 0.32. What is the ratio of the Number of enrolments of both sexes of Ireland in 1986 to that in 1994?
Make the answer very short. 0.55. What is the ratio of the Number of enrolments of both sexes in Myanmar in 1986 to that in 1994?
Your response must be concise. 0.98. What is the ratio of the Number of enrolments of both sexes of Dominica in 1987 to that in 1990?
Offer a very short reply. 0.12. What is the ratio of the Number of enrolments of both sexes in Ireland in 1987 to that in 1990?
Provide a succinct answer. 0.96. What is the ratio of the Number of enrolments of both sexes of Myanmar in 1987 to that in 1990?
Your answer should be compact. 1.06. What is the ratio of the Number of enrolments of both sexes of Sub-Saharan Africa (all income levels) in 1987 to that in 1994?
Give a very brief answer. 0.92. What is the ratio of the Number of enrolments of both sexes in Dominica in 1987 to that in 1994?
Keep it short and to the point. 0.09. What is the ratio of the Number of enrolments of both sexes in Ireland in 1987 to that in 1994?
Provide a short and direct response. 0.55. What is the ratio of the Number of enrolments of both sexes in Myanmar in 1987 to that in 1994?
Provide a succinct answer. 1.09. What is the ratio of the Number of enrolments of both sexes in Sub-Saharan Africa (all income levels) in 1990 to that in 1994?
Your answer should be compact. 0.93. What is the ratio of the Number of enrolments of both sexes in Dominica in 1990 to that in 1994?
Your answer should be very brief. 0.76. What is the ratio of the Number of enrolments of both sexes of Ireland in 1990 to that in 1994?
Give a very brief answer. 0.58. What is the ratio of the Number of enrolments of both sexes of Myanmar in 1990 to that in 1994?
Keep it short and to the point. 1.04. What is the difference between the highest and the second highest Number of enrolments of both sexes in Sub-Saharan Africa (all income levels)?
Your answer should be compact. 1.00e+05. What is the difference between the highest and the second highest Number of enrolments of both sexes of Dominica?
Make the answer very short. 196. What is the difference between the highest and the second highest Number of enrolments of both sexes in Ireland?
Make the answer very short. 1.73e+04. What is the difference between the highest and the second highest Number of enrolments of both sexes in Myanmar?
Your answer should be very brief. 6200. What is the difference between the highest and the lowest Number of enrolments of both sexes in Sub-Saharan Africa (all income levels)?
Your response must be concise. 6.29e+05. What is the difference between the highest and the lowest Number of enrolments of both sexes in Dominica?
Ensure brevity in your answer.  730. What is the difference between the highest and the lowest Number of enrolments of both sexes in Ireland?
Offer a terse response. 2.63e+04. What is the difference between the highest and the lowest Number of enrolments of both sexes in Myanmar?
Provide a short and direct response. 1.28e+04. 